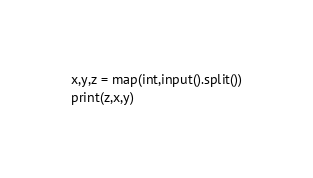Convert code to text. <code><loc_0><loc_0><loc_500><loc_500><_Python_>x,y,z = map(int,input().split())
print(z,x,y)</code> 